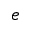Convert formula to latex. <formula><loc_0><loc_0><loc_500><loc_500>e</formula> 